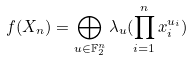Convert formula to latex. <formula><loc_0><loc_0><loc_500><loc_500>f ( X _ { n } ) = \bigoplus _ { u \in \mathbb { F } _ { 2 } ^ { n } } \lambda _ { u } ( \prod _ { i = 1 } ^ { n } x _ { i } ^ { u _ { i } } )</formula> 